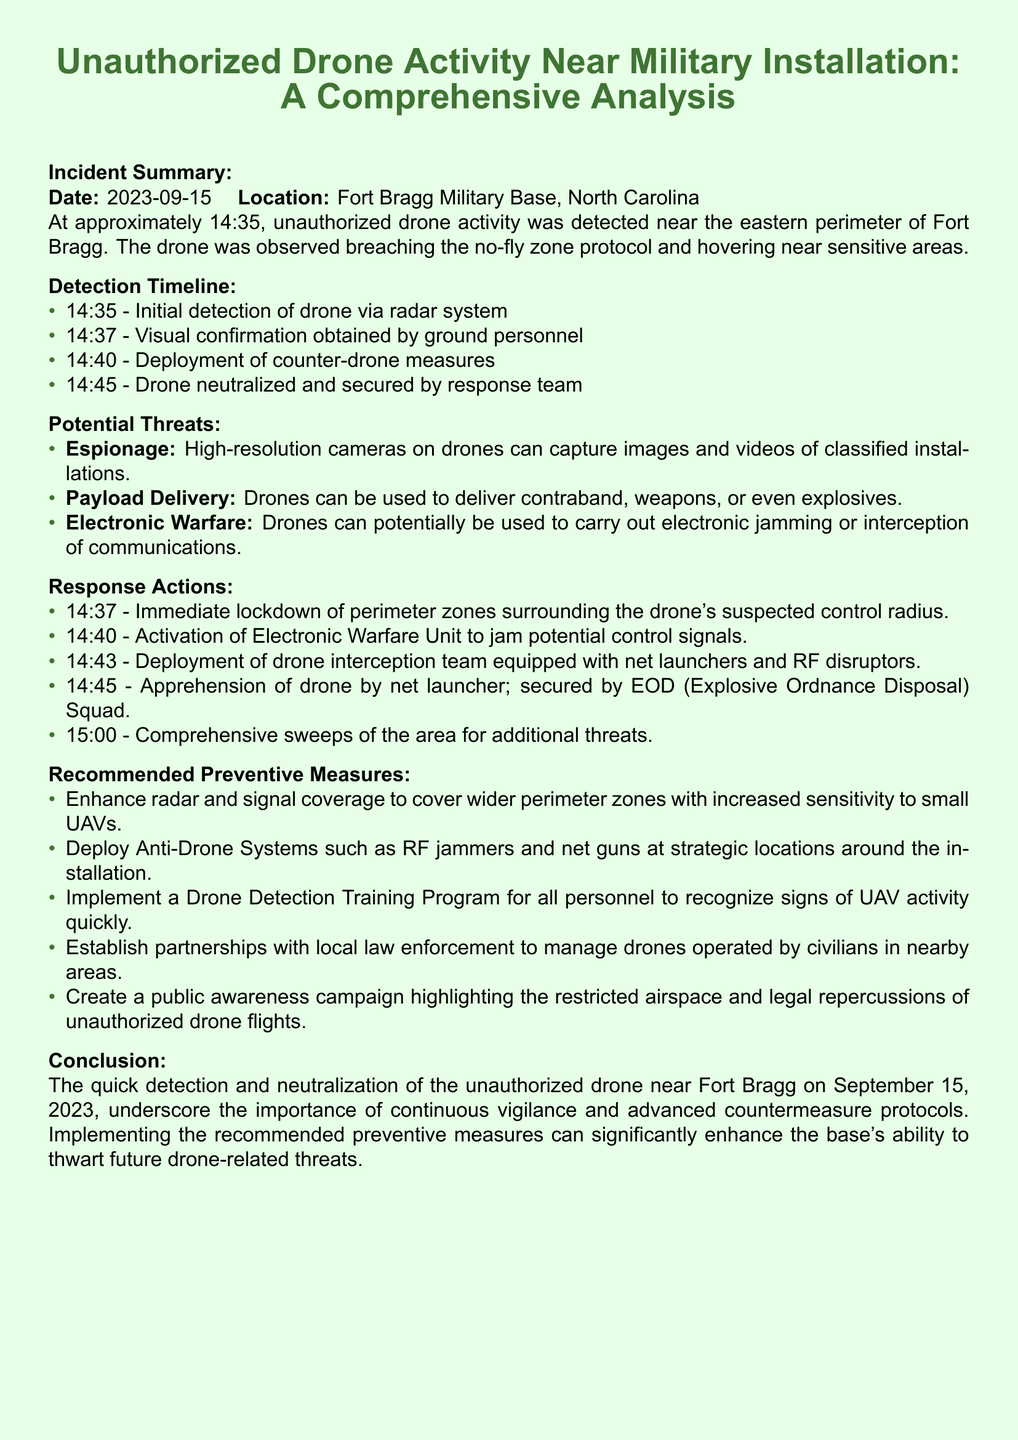what was the date of the incident? The document states that the incident occurred on September 15, 2023.
Answer: September 15, 2023 what time was the drone first detected? The radar system detected the drone at 14:35.
Answer: 14:35 what measures were taken to neutralize the drone? The response actions included apprehending the drone using a net launcher and securing it by the EOD Squad.
Answer: Net launcher; EOD Squad what were the three potential threats listed? The threats mentioned include espionage, payload delivery, and electronic warfare.
Answer: Espionage, payload delivery, electronic warfare how long did it take from initial detection to drone neutralization? The drone was neutralized 10 minutes after its initial detection.
Answer: 10 minutes what is one recommended preventive measure mentioned? The document suggests enhancing radar and signal coverage.
Answer: Enhance radar and signal coverage what unit was activated to jam control signals? The Electronic Warfare Unit was activated.
Answer: Electronic Warfare Unit what was the visual confirmation time? Visual confirmation was obtained at 14:37.
Answer: 14:37 what activities were conducted at 15:00? Comprehensive sweeps of the area were conducted for additional threats.
Answer: Comprehensive sweeps of the area 